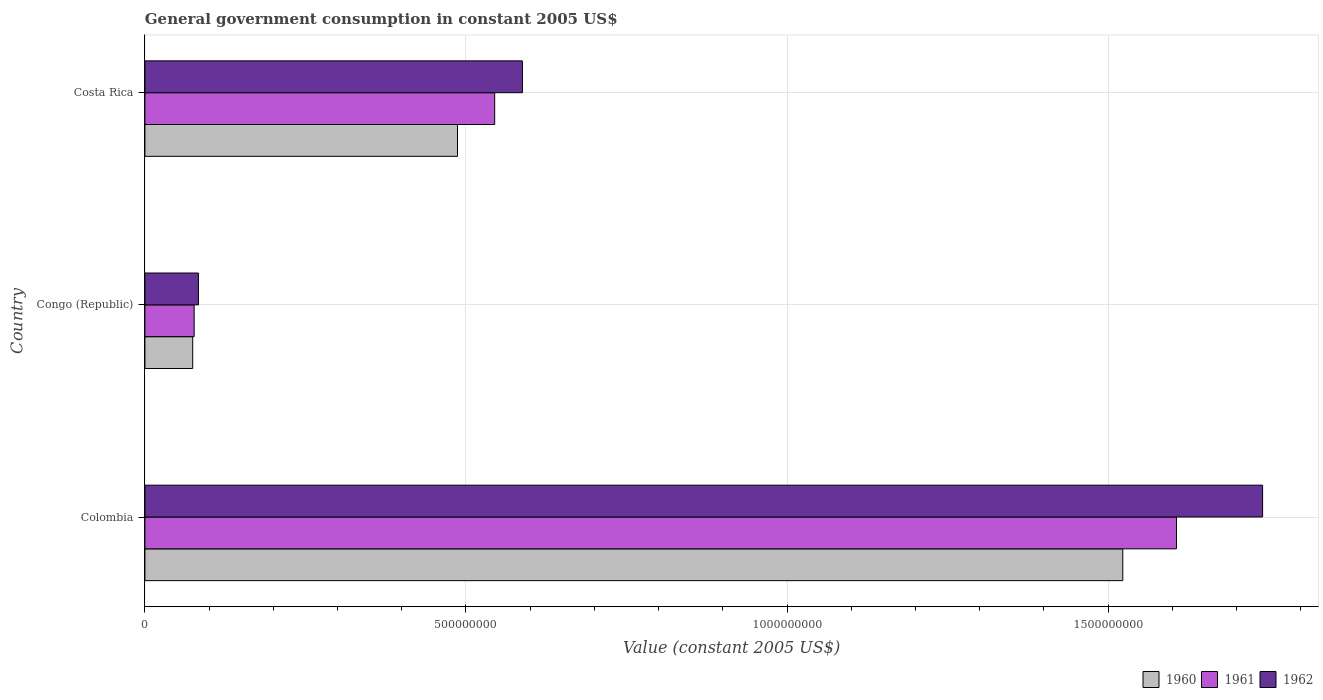Are the number of bars on each tick of the Y-axis equal?
Make the answer very short. Yes. How many bars are there on the 1st tick from the top?
Your answer should be compact. 3. How many bars are there on the 1st tick from the bottom?
Ensure brevity in your answer.  3. What is the label of the 3rd group of bars from the top?
Your answer should be very brief. Colombia. In how many cases, is the number of bars for a given country not equal to the number of legend labels?
Offer a terse response. 0. What is the government conusmption in 1962 in Colombia?
Your answer should be compact. 1.74e+09. Across all countries, what is the maximum government conusmption in 1962?
Your answer should be compact. 1.74e+09. Across all countries, what is the minimum government conusmption in 1960?
Your answer should be very brief. 7.44e+07. In which country was the government conusmption in 1961 maximum?
Keep it short and to the point. Colombia. In which country was the government conusmption in 1960 minimum?
Provide a succinct answer. Congo (Republic). What is the total government conusmption in 1962 in the graph?
Provide a succinct answer. 2.41e+09. What is the difference between the government conusmption in 1960 in Colombia and that in Congo (Republic)?
Your answer should be very brief. 1.45e+09. What is the difference between the government conusmption in 1960 in Costa Rica and the government conusmption in 1961 in Colombia?
Keep it short and to the point. -1.12e+09. What is the average government conusmption in 1962 per country?
Provide a short and direct response. 8.04e+08. What is the difference between the government conusmption in 1960 and government conusmption in 1961 in Costa Rica?
Make the answer very short. -5.79e+07. In how many countries, is the government conusmption in 1962 greater than 900000000 US$?
Provide a short and direct response. 1. What is the ratio of the government conusmption in 1960 in Colombia to that in Costa Rica?
Provide a short and direct response. 3.13. Is the government conusmption in 1960 in Congo (Republic) less than that in Costa Rica?
Provide a succinct answer. Yes. What is the difference between the highest and the second highest government conusmption in 1960?
Offer a very short reply. 1.04e+09. What is the difference between the highest and the lowest government conusmption in 1962?
Your answer should be very brief. 1.66e+09. In how many countries, is the government conusmption in 1961 greater than the average government conusmption in 1961 taken over all countries?
Make the answer very short. 1. Is the sum of the government conusmption in 1961 in Colombia and Congo (Republic) greater than the maximum government conusmption in 1962 across all countries?
Make the answer very short. No. What does the 2nd bar from the bottom in Colombia represents?
Your answer should be very brief. 1961. Are all the bars in the graph horizontal?
Keep it short and to the point. Yes. What is the difference between two consecutive major ticks on the X-axis?
Provide a succinct answer. 5.00e+08. Are the values on the major ticks of X-axis written in scientific E-notation?
Keep it short and to the point. No. Does the graph contain grids?
Your response must be concise. Yes. Where does the legend appear in the graph?
Keep it short and to the point. Bottom right. How many legend labels are there?
Your response must be concise. 3. What is the title of the graph?
Provide a succinct answer. General government consumption in constant 2005 US$. What is the label or title of the X-axis?
Keep it short and to the point. Value (constant 2005 US$). What is the Value (constant 2005 US$) in 1960 in Colombia?
Offer a terse response. 1.52e+09. What is the Value (constant 2005 US$) of 1961 in Colombia?
Make the answer very short. 1.61e+09. What is the Value (constant 2005 US$) in 1962 in Colombia?
Ensure brevity in your answer.  1.74e+09. What is the Value (constant 2005 US$) of 1960 in Congo (Republic)?
Your response must be concise. 7.44e+07. What is the Value (constant 2005 US$) of 1961 in Congo (Republic)?
Provide a succinct answer. 7.67e+07. What is the Value (constant 2005 US$) of 1962 in Congo (Republic)?
Your answer should be compact. 8.33e+07. What is the Value (constant 2005 US$) of 1960 in Costa Rica?
Provide a succinct answer. 4.87e+08. What is the Value (constant 2005 US$) of 1961 in Costa Rica?
Keep it short and to the point. 5.45e+08. What is the Value (constant 2005 US$) in 1962 in Costa Rica?
Keep it short and to the point. 5.88e+08. Across all countries, what is the maximum Value (constant 2005 US$) of 1960?
Offer a terse response. 1.52e+09. Across all countries, what is the maximum Value (constant 2005 US$) of 1961?
Offer a very short reply. 1.61e+09. Across all countries, what is the maximum Value (constant 2005 US$) of 1962?
Keep it short and to the point. 1.74e+09. Across all countries, what is the minimum Value (constant 2005 US$) in 1960?
Your response must be concise. 7.44e+07. Across all countries, what is the minimum Value (constant 2005 US$) in 1961?
Provide a short and direct response. 7.67e+07. Across all countries, what is the minimum Value (constant 2005 US$) of 1962?
Offer a very short reply. 8.33e+07. What is the total Value (constant 2005 US$) in 1960 in the graph?
Offer a very short reply. 2.08e+09. What is the total Value (constant 2005 US$) in 1961 in the graph?
Your response must be concise. 2.23e+09. What is the total Value (constant 2005 US$) of 1962 in the graph?
Give a very brief answer. 2.41e+09. What is the difference between the Value (constant 2005 US$) in 1960 in Colombia and that in Congo (Republic)?
Offer a terse response. 1.45e+09. What is the difference between the Value (constant 2005 US$) of 1961 in Colombia and that in Congo (Republic)?
Your answer should be very brief. 1.53e+09. What is the difference between the Value (constant 2005 US$) of 1962 in Colombia and that in Congo (Republic)?
Provide a short and direct response. 1.66e+09. What is the difference between the Value (constant 2005 US$) of 1960 in Colombia and that in Costa Rica?
Keep it short and to the point. 1.04e+09. What is the difference between the Value (constant 2005 US$) in 1961 in Colombia and that in Costa Rica?
Provide a short and direct response. 1.06e+09. What is the difference between the Value (constant 2005 US$) of 1962 in Colombia and that in Costa Rica?
Make the answer very short. 1.15e+09. What is the difference between the Value (constant 2005 US$) in 1960 in Congo (Republic) and that in Costa Rica?
Your answer should be compact. -4.12e+08. What is the difference between the Value (constant 2005 US$) of 1961 in Congo (Republic) and that in Costa Rica?
Your answer should be compact. -4.68e+08. What is the difference between the Value (constant 2005 US$) in 1962 in Congo (Republic) and that in Costa Rica?
Offer a very short reply. -5.05e+08. What is the difference between the Value (constant 2005 US$) in 1960 in Colombia and the Value (constant 2005 US$) in 1961 in Congo (Republic)?
Keep it short and to the point. 1.45e+09. What is the difference between the Value (constant 2005 US$) in 1960 in Colombia and the Value (constant 2005 US$) in 1962 in Congo (Republic)?
Keep it short and to the point. 1.44e+09. What is the difference between the Value (constant 2005 US$) of 1961 in Colombia and the Value (constant 2005 US$) of 1962 in Congo (Republic)?
Offer a terse response. 1.52e+09. What is the difference between the Value (constant 2005 US$) of 1960 in Colombia and the Value (constant 2005 US$) of 1961 in Costa Rica?
Offer a terse response. 9.78e+08. What is the difference between the Value (constant 2005 US$) in 1960 in Colombia and the Value (constant 2005 US$) in 1962 in Costa Rica?
Provide a succinct answer. 9.35e+08. What is the difference between the Value (constant 2005 US$) in 1961 in Colombia and the Value (constant 2005 US$) in 1962 in Costa Rica?
Make the answer very short. 1.02e+09. What is the difference between the Value (constant 2005 US$) in 1960 in Congo (Republic) and the Value (constant 2005 US$) in 1961 in Costa Rica?
Ensure brevity in your answer.  -4.70e+08. What is the difference between the Value (constant 2005 US$) of 1960 in Congo (Republic) and the Value (constant 2005 US$) of 1962 in Costa Rica?
Your answer should be very brief. -5.13e+08. What is the difference between the Value (constant 2005 US$) of 1961 in Congo (Republic) and the Value (constant 2005 US$) of 1962 in Costa Rica?
Your answer should be very brief. -5.11e+08. What is the average Value (constant 2005 US$) of 1960 per country?
Give a very brief answer. 6.95e+08. What is the average Value (constant 2005 US$) of 1961 per country?
Ensure brevity in your answer.  7.43e+08. What is the average Value (constant 2005 US$) of 1962 per country?
Give a very brief answer. 8.04e+08. What is the difference between the Value (constant 2005 US$) in 1960 and Value (constant 2005 US$) in 1961 in Colombia?
Offer a very short reply. -8.37e+07. What is the difference between the Value (constant 2005 US$) in 1960 and Value (constant 2005 US$) in 1962 in Colombia?
Offer a terse response. -2.18e+08. What is the difference between the Value (constant 2005 US$) in 1961 and Value (constant 2005 US$) in 1962 in Colombia?
Your response must be concise. -1.34e+08. What is the difference between the Value (constant 2005 US$) of 1960 and Value (constant 2005 US$) of 1961 in Congo (Republic)?
Your answer should be compact. -2.22e+06. What is the difference between the Value (constant 2005 US$) of 1960 and Value (constant 2005 US$) of 1962 in Congo (Republic)?
Offer a very short reply. -8.89e+06. What is the difference between the Value (constant 2005 US$) in 1961 and Value (constant 2005 US$) in 1962 in Congo (Republic)?
Provide a short and direct response. -6.67e+06. What is the difference between the Value (constant 2005 US$) of 1960 and Value (constant 2005 US$) of 1961 in Costa Rica?
Your response must be concise. -5.79e+07. What is the difference between the Value (constant 2005 US$) of 1960 and Value (constant 2005 US$) of 1962 in Costa Rica?
Make the answer very short. -1.01e+08. What is the difference between the Value (constant 2005 US$) of 1961 and Value (constant 2005 US$) of 1962 in Costa Rica?
Keep it short and to the point. -4.32e+07. What is the ratio of the Value (constant 2005 US$) of 1960 in Colombia to that in Congo (Republic)?
Provide a succinct answer. 20.46. What is the ratio of the Value (constant 2005 US$) in 1961 in Colombia to that in Congo (Republic)?
Keep it short and to the point. 20.96. What is the ratio of the Value (constant 2005 US$) of 1962 in Colombia to that in Congo (Republic)?
Give a very brief answer. 20.89. What is the ratio of the Value (constant 2005 US$) of 1960 in Colombia to that in Costa Rica?
Provide a succinct answer. 3.13. What is the ratio of the Value (constant 2005 US$) of 1961 in Colombia to that in Costa Rica?
Provide a short and direct response. 2.95. What is the ratio of the Value (constant 2005 US$) in 1962 in Colombia to that in Costa Rica?
Keep it short and to the point. 2.96. What is the ratio of the Value (constant 2005 US$) of 1960 in Congo (Republic) to that in Costa Rica?
Your answer should be compact. 0.15. What is the ratio of the Value (constant 2005 US$) of 1961 in Congo (Republic) to that in Costa Rica?
Offer a terse response. 0.14. What is the ratio of the Value (constant 2005 US$) in 1962 in Congo (Republic) to that in Costa Rica?
Your response must be concise. 0.14. What is the difference between the highest and the second highest Value (constant 2005 US$) of 1960?
Make the answer very short. 1.04e+09. What is the difference between the highest and the second highest Value (constant 2005 US$) in 1961?
Your answer should be compact. 1.06e+09. What is the difference between the highest and the second highest Value (constant 2005 US$) of 1962?
Ensure brevity in your answer.  1.15e+09. What is the difference between the highest and the lowest Value (constant 2005 US$) in 1960?
Ensure brevity in your answer.  1.45e+09. What is the difference between the highest and the lowest Value (constant 2005 US$) in 1961?
Provide a succinct answer. 1.53e+09. What is the difference between the highest and the lowest Value (constant 2005 US$) in 1962?
Provide a short and direct response. 1.66e+09. 